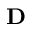Convert formula to latex. <formula><loc_0><loc_0><loc_500><loc_500>D</formula> 